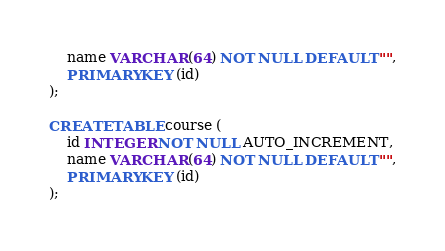Convert code to text. <code><loc_0><loc_0><loc_500><loc_500><_SQL_>    name VARCHAR (64) NOT NULL DEFAULT "",
    PRIMARY KEY (id)
);

CREATE TABLE course (
    id INTEGER NOT NULL AUTO_INCREMENT,
    name VARCHAR (64) NOT NULL DEFAULT "",
    PRIMARY KEY (id)
);</code> 